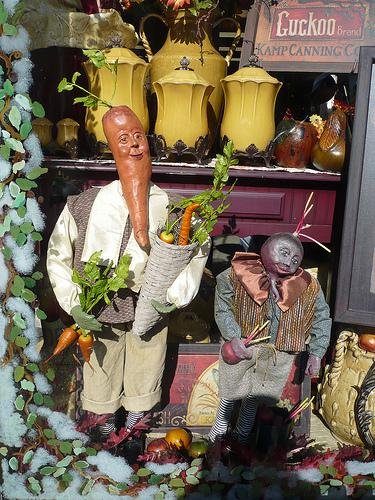Question: why ceramic vegetable faces?
Choices:
A. Display.
B. Models.
C. Amusement.
D. Education.
Answer with the letter. Answer: C Question: who decorated the window?
Choices:
A. Students.
B. Monkeys.
C. A contest winner.
D. The store owner or a worker.
Answer with the letter. Answer: D Question: what color are the canisters?
Choices:
A. Yellow.
B. Harvest gold.
C. Navy blue.
D. Bright green.
Answer with the letter. Answer: B Question: how is the displayed accessed?
Choices:
A. From inside.
B. Through the window.
C. Through the door.
D. By breaking the glass.
Answer with the letter. Answer: A Question: what caused the shadow?
Choices:
A. The person blocking the sun.
B. Car.
C. Horse.
D. Building.
Answer with the letter. Answer: A 